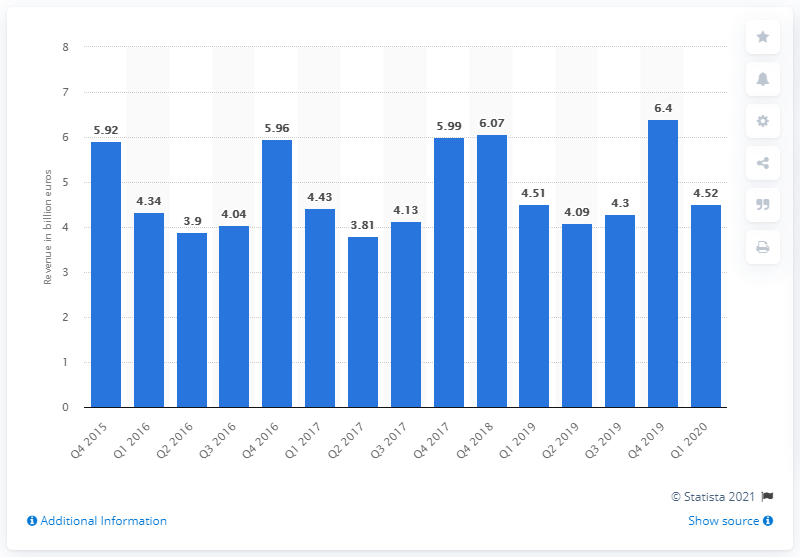Identify some key points in this picture. In the fourth quarter of 2018, the revenues from small domestic appliances were approximately 6.07. The revenue generated by the Small Diameter Acceptance (SDA) in the first quarter of 2020 was 4.52. 